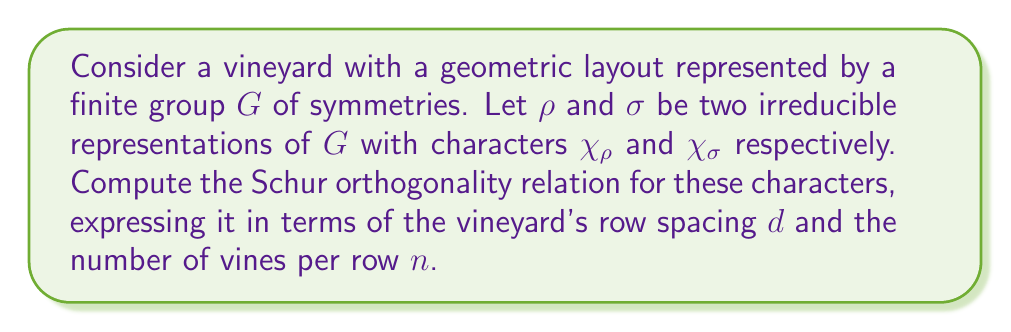Solve this math problem. Let's approach this step-by-step:

1) The Schur orthogonality relation for characters of irreducible representations is given by:

   $$\frac{1}{|G|} \sum_{g \in G} \chi_\rho(g) \overline{\chi_\sigma(g)} = \delta_{\rho\sigma}$$

   where $|G|$ is the order of the group, and $\delta_{\rho\sigma}$ is the Kronecker delta.

2) In our vineyard context, we can relate the group order $|G|$ to the vineyard layout. Let's assume the vineyard has $n$ vines per row and the row spacing is $d$.

3) We can model the symmetry group $G$ as a direct product of cyclic groups:
   $G \cong C_n \times C_d$, where $C_n$ represents rotations of vines within a row, and $C_d$ represents translations between rows.

4) The order of this group is $|G| = n \cdot d$.

5) Substituting this into our Schur orthogonality relation:

   $$\frac{1}{nd} \sum_{g \in G} \chi_\rho(g) \overline{\chi_\sigma(g)} = \delta_{\rho\sigma}$$

6) To make this more specific to our vineyard, we can express $g$ in terms of its components $(r,t)$ where $r \in C_n$ and $t \in C_d$:

   $$\frac{1}{nd} \sum_{r=0}^{n-1} \sum_{t=0}^{d-1} \chi_\rho(r,t) \overline{\chi_\sigma(r,t)} = \delta_{\rho\sigma}$$

This is the Schur orthogonality relation expressed in terms of our vineyard's geometric layout.
Answer: $$\frac{1}{nd} \sum_{r=0}^{n-1} \sum_{t=0}^{d-1} \chi_\rho(r,t) \overline{\chi_\sigma(r,t)} = \delta_{\rho\sigma}$$ 